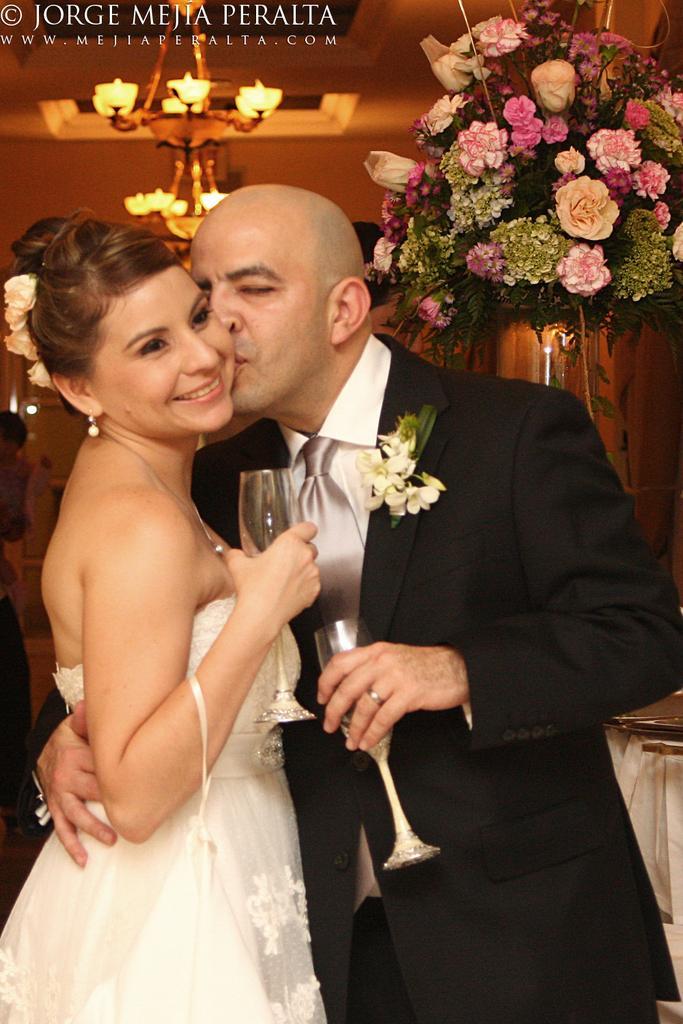Can you describe this image briefly? In this picture we can see man wore blazer, tie holding girl and kissing her where this two are holding glasses in their hands and in background we can see chandelier, flowers. 